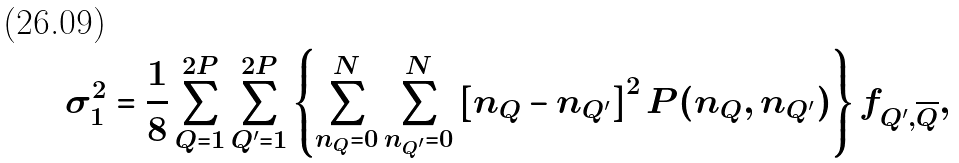<formula> <loc_0><loc_0><loc_500><loc_500>\sigma _ { 1 } ^ { 2 } = \frac { 1 } { 8 } \sum _ { Q = 1 } ^ { 2 P } \sum _ { Q ^ { \prime } = 1 } ^ { 2 P } \left \{ \sum _ { n _ { Q } = 0 } ^ { N } \sum _ { n _ { Q ^ { \prime } } = 0 } ^ { N } \left [ n _ { Q } - n _ { Q ^ { \prime } } \right ] ^ { 2 } P ( n _ { Q } , n _ { Q ^ { \prime } } ) \right \} f _ { Q ^ { \prime } , \overline { Q } } ,</formula> 